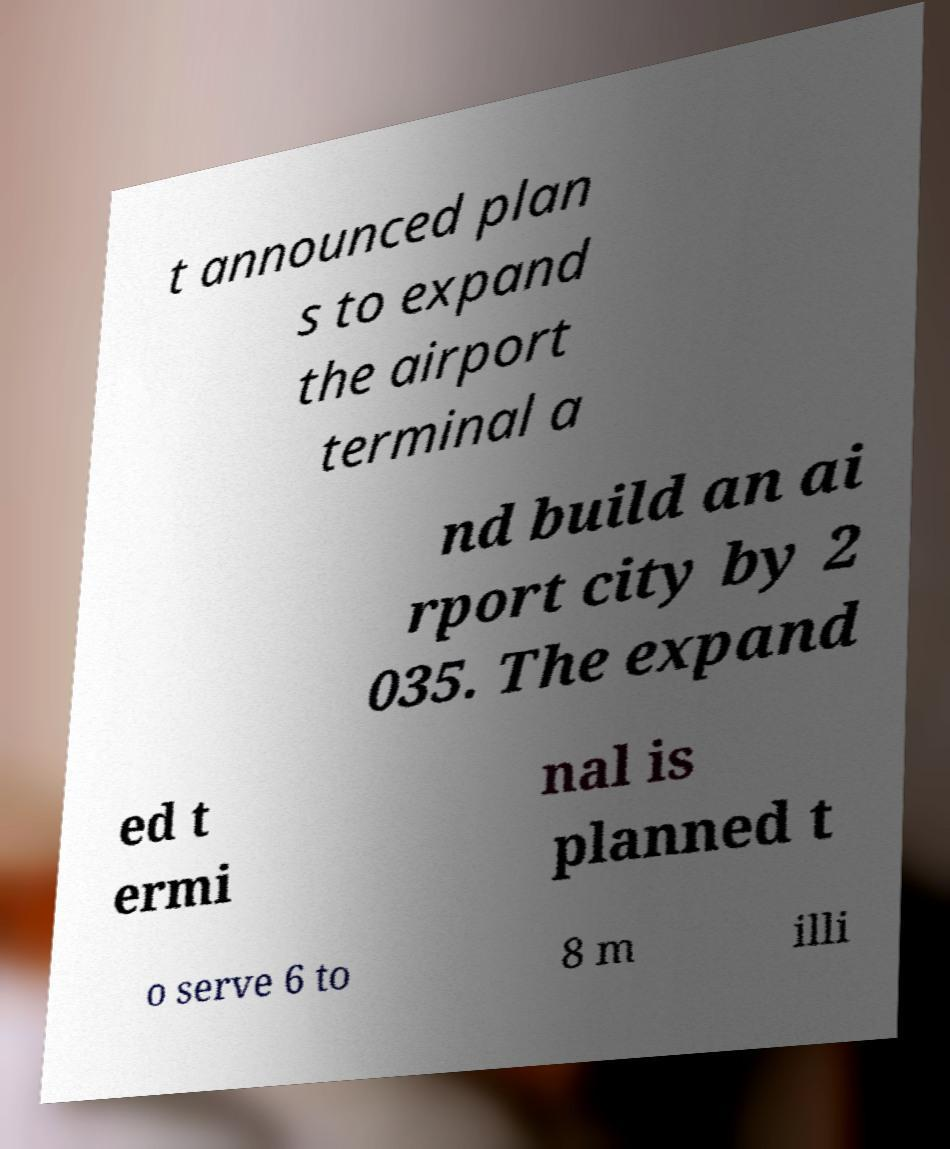Could you assist in decoding the text presented in this image and type it out clearly? t announced plan s to expand the airport terminal a nd build an ai rport city by 2 035. The expand ed t ermi nal is planned t o serve 6 to 8 m illi 